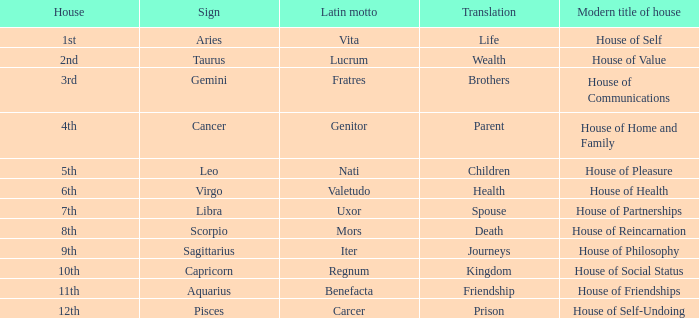Could you parse the entire table as a dict? {'header': ['House', 'Sign', 'Latin motto', 'Translation', 'Modern title of house'], 'rows': [['1st', 'Aries', 'Vita', 'Life', 'House of Self'], ['2nd', 'Taurus', 'Lucrum', 'Wealth', 'House of Value'], ['3rd', 'Gemini', 'Fratres', 'Brothers', 'House of Communications'], ['4th', 'Cancer', 'Genitor', 'Parent', 'House of Home and Family'], ['5th', 'Leo', 'Nati', 'Children', 'House of Pleasure'], ['6th', 'Virgo', 'Valetudo', 'Health', 'House of Health'], ['7th', 'Libra', 'Uxor', 'Spouse', 'House of Partnerships'], ['8th', 'Scorpio', 'Mors', 'Death', 'House of Reincarnation'], ['9th', 'Sagittarius', 'Iter', 'Journeys', 'House of Philosophy'], ['10th', 'Capricorn', 'Regnum', 'Kingdom', 'House of Social Status'], ['11th', 'Aquarius', 'Benefacta', 'Friendship', 'House of Friendships'], ['12th', 'Pisces', 'Carcer', 'Prison', 'House of Self-Undoing']]} Which indication has a current house title called house of partnerships? Libra. 